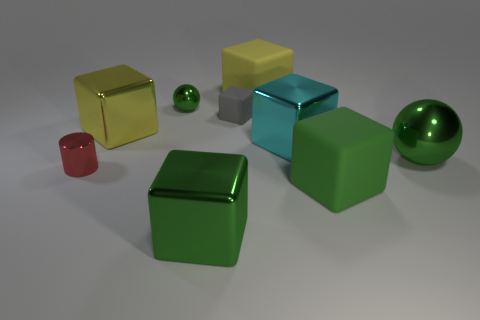Subtract all cyan cubes. How many cubes are left? 5 Subtract all large cyan metal blocks. How many blocks are left? 5 Subtract all purple cylinders. Subtract all purple balls. How many cylinders are left? 1 Add 1 small gray matte objects. How many objects exist? 10 Subtract all spheres. How many objects are left? 7 Add 1 large yellow metal blocks. How many large yellow metal blocks are left? 2 Add 3 large things. How many large things exist? 9 Subtract 0 cyan cylinders. How many objects are left? 9 Subtract all large cyan metal cubes. Subtract all gray rubber cubes. How many objects are left? 7 